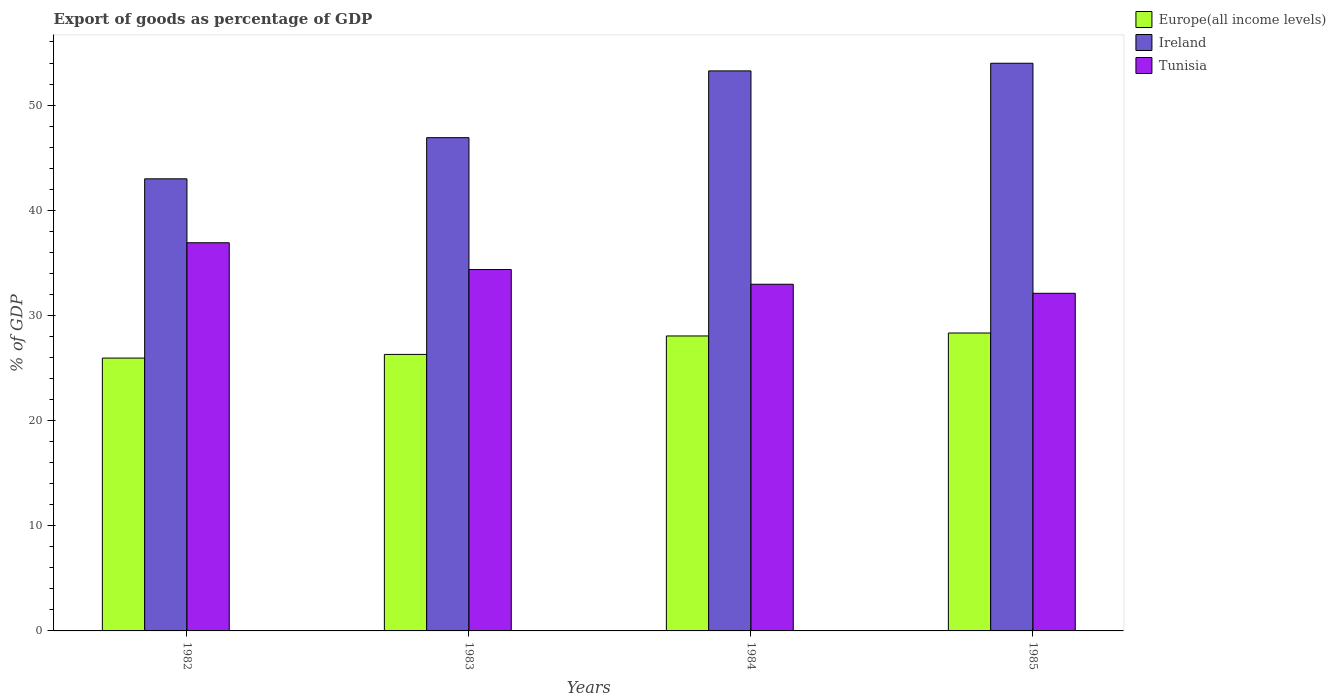How many groups of bars are there?
Provide a short and direct response. 4. Are the number of bars per tick equal to the number of legend labels?
Offer a terse response. Yes. Are the number of bars on each tick of the X-axis equal?
Provide a short and direct response. Yes. How many bars are there on the 2nd tick from the left?
Your answer should be compact. 3. What is the label of the 2nd group of bars from the left?
Offer a very short reply. 1983. What is the export of goods as percentage of GDP in Tunisia in 1983?
Your answer should be compact. 34.36. Across all years, what is the maximum export of goods as percentage of GDP in Europe(all income levels)?
Give a very brief answer. 28.33. Across all years, what is the minimum export of goods as percentage of GDP in Ireland?
Your answer should be compact. 42.99. In which year was the export of goods as percentage of GDP in Ireland maximum?
Give a very brief answer. 1985. In which year was the export of goods as percentage of GDP in Europe(all income levels) minimum?
Keep it short and to the point. 1982. What is the total export of goods as percentage of GDP in Europe(all income levels) in the graph?
Your answer should be compact. 108.61. What is the difference between the export of goods as percentage of GDP in Europe(all income levels) in 1983 and that in 1985?
Your answer should be very brief. -2.04. What is the difference between the export of goods as percentage of GDP in Europe(all income levels) in 1985 and the export of goods as percentage of GDP in Tunisia in 1984?
Offer a terse response. -4.64. What is the average export of goods as percentage of GDP in Tunisia per year?
Your answer should be very brief. 34.09. In the year 1985, what is the difference between the export of goods as percentage of GDP in Ireland and export of goods as percentage of GDP in Europe(all income levels)?
Give a very brief answer. 25.65. In how many years, is the export of goods as percentage of GDP in Europe(all income levels) greater than 44 %?
Provide a short and direct response. 0. What is the ratio of the export of goods as percentage of GDP in Tunisia in 1982 to that in 1983?
Offer a very short reply. 1.07. What is the difference between the highest and the second highest export of goods as percentage of GDP in Ireland?
Your answer should be very brief. 0.73. What is the difference between the highest and the lowest export of goods as percentage of GDP in Europe(all income levels)?
Provide a succinct answer. 2.38. What does the 3rd bar from the left in 1982 represents?
Provide a short and direct response. Tunisia. What does the 1st bar from the right in 1985 represents?
Give a very brief answer. Tunisia. How many bars are there?
Give a very brief answer. 12. Are all the bars in the graph horizontal?
Keep it short and to the point. No. How many years are there in the graph?
Provide a succinct answer. 4. What is the difference between two consecutive major ticks on the Y-axis?
Provide a succinct answer. 10. Does the graph contain any zero values?
Your response must be concise. No. Does the graph contain grids?
Make the answer very short. No. Where does the legend appear in the graph?
Your answer should be very brief. Top right. What is the title of the graph?
Provide a succinct answer. Export of goods as percentage of GDP. Does "Congo (Democratic)" appear as one of the legend labels in the graph?
Offer a very short reply. No. What is the label or title of the X-axis?
Make the answer very short. Years. What is the label or title of the Y-axis?
Offer a very short reply. % of GDP. What is the % of GDP in Europe(all income levels) in 1982?
Your response must be concise. 25.94. What is the % of GDP in Ireland in 1982?
Provide a short and direct response. 42.99. What is the % of GDP in Tunisia in 1982?
Your answer should be very brief. 36.91. What is the % of GDP in Europe(all income levels) in 1983?
Offer a very short reply. 26.29. What is the % of GDP in Ireland in 1983?
Your answer should be very brief. 46.9. What is the % of GDP of Tunisia in 1983?
Your answer should be very brief. 34.36. What is the % of GDP in Europe(all income levels) in 1984?
Give a very brief answer. 28.05. What is the % of GDP in Ireland in 1984?
Keep it short and to the point. 53.25. What is the % of GDP in Tunisia in 1984?
Give a very brief answer. 32.96. What is the % of GDP in Europe(all income levels) in 1985?
Make the answer very short. 28.33. What is the % of GDP in Ireland in 1985?
Your response must be concise. 53.98. What is the % of GDP of Tunisia in 1985?
Offer a very short reply. 32.1. Across all years, what is the maximum % of GDP of Europe(all income levels)?
Provide a succinct answer. 28.33. Across all years, what is the maximum % of GDP in Ireland?
Your response must be concise. 53.98. Across all years, what is the maximum % of GDP in Tunisia?
Make the answer very short. 36.91. Across all years, what is the minimum % of GDP in Europe(all income levels)?
Your answer should be compact. 25.94. Across all years, what is the minimum % of GDP in Ireland?
Ensure brevity in your answer.  42.99. Across all years, what is the minimum % of GDP in Tunisia?
Give a very brief answer. 32.1. What is the total % of GDP of Europe(all income levels) in the graph?
Ensure brevity in your answer.  108.61. What is the total % of GDP of Ireland in the graph?
Provide a succinct answer. 197.12. What is the total % of GDP in Tunisia in the graph?
Offer a very short reply. 136.34. What is the difference between the % of GDP of Europe(all income levels) in 1982 and that in 1983?
Keep it short and to the point. -0.35. What is the difference between the % of GDP of Ireland in 1982 and that in 1983?
Keep it short and to the point. -3.91. What is the difference between the % of GDP of Tunisia in 1982 and that in 1983?
Make the answer very short. 2.55. What is the difference between the % of GDP in Europe(all income levels) in 1982 and that in 1984?
Make the answer very short. -2.1. What is the difference between the % of GDP in Ireland in 1982 and that in 1984?
Offer a very short reply. -10.26. What is the difference between the % of GDP in Tunisia in 1982 and that in 1984?
Provide a short and direct response. 3.95. What is the difference between the % of GDP in Europe(all income levels) in 1982 and that in 1985?
Ensure brevity in your answer.  -2.38. What is the difference between the % of GDP of Ireland in 1982 and that in 1985?
Provide a short and direct response. -10.99. What is the difference between the % of GDP in Tunisia in 1982 and that in 1985?
Keep it short and to the point. 4.81. What is the difference between the % of GDP in Europe(all income levels) in 1983 and that in 1984?
Offer a terse response. -1.75. What is the difference between the % of GDP of Ireland in 1983 and that in 1984?
Your answer should be compact. -6.35. What is the difference between the % of GDP in Tunisia in 1983 and that in 1984?
Offer a terse response. 1.4. What is the difference between the % of GDP in Europe(all income levels) in 1983 and that in 1985?
Offer a very short reply. -2.04. What is the difference between the % of GDP in Ireland in 1983 and that in 1985?
Make the answer very short. -7.08. What is the difference between the % of GDP in Tunisia in 1983 and that in 1985?
Keep it short and to the point. 2.26. What is the difference between the % of GDP of Europe(all income levels) in 1984 and that in 1985?
Your answer should be very brief. -0.28. What is the difference between the % of GDP of Ireland in 1984 and that in 1985?
Offer a very short reply. -0.73. What is the difference between the % of GDP in Tunisia in 1984 and that in 1985?
Provide a short and direct response. 0.86. What is the difference between the % of GDP in Europe(all income levels) in 1982 and the % of GDP in Ireland in 1983?
Offer a terse response. -20.96. What is the difference between the % of GDP of Europe(all income levels) in 1982 and the % of GDP of Tunisia in 1983?
Ensure brevity in your answer.  -8.42. What is the difference between the % of GDP of Ireland in 1982 and the % of GDP of Tunisia in 1983?
Offer a terse response. 8.62. What is the difference between the % of GDP of Europe(all income levels) in 1982 and the % of GDP of Ireland in 1984?
Your answer should be compact. -27.31. What is the difference between the % of GDP of Europe(all income levels) in 1982 and the % of GDP of Tunisia in 1984?
Your response must be concise. -7.02. What is the difference between the % of GDP of Ireland in 1982 and the % of GDP of Tunisia in 1984?
Ensure brevity in your answer.  10.03. What is the difference between the % of GDP of Europe(all income levels) in 1982 and the % of GDP of Ireland in 1985?
Keep it short and to the point. -28.03. What is the difference between the % of GDP of Europe(all income levels) in 1982 and the % of GDP of Tunisia in 1985?
Your answer should be very brief. -6.16. What is the difference between the % of GDP in Ireland in 1982 and the % of GDP in Tunisia in 1985?
Keep it short and to the point. 10.89. What is the difference between the % of GDP in Europe(all income levels) in 1983 and the % of GDP in Ireland in 1984?
Your answer should be very brief. -26.96. What is the difference between the % of GDP of Europe(all income levels) in 1983 and the % of GDP of Tunisia in 1984?
Your answer should be compact. -6.67. What is the difference between the % of GDP of Ireland in 1983 and the % of GDP of Tunisia in 1984?
Your answer should be compact. 13.94. What is the difference between the % of GDP in Europe(all income levels) in 1983 and the % of GDP in Ireland in 1985?
Your response must be concise. -27.69. What is the difference between the % of GDP of Europe(all income levels) in 1983 and the % of GDP of Tunisia in 1985?
Keep it short and to the point. -5.81. What is the difference between the % of GDP in Ireland in 1983 and the % of GDP in Tunisia in 1985?
Offer a terse response. 14.8. What is the difference between the % of GDP of Europe(all income levels) in 1984 and the % of GDP of Ireland in 1985?
Offer a very short reply. -25.93. What is the difference between the % of GDP in Europe(all income levels) in 1984 and the % of GDP in Tunisia in 1985?
Your answer should be very brief. -4.06. What is the difference between the % of GDP of Ireland in 1984 and the % of GDP of Tunisia in 1985?
Your answer should be very brief. 21.15. What is the average % of GDP of Europe(all income levels) per year?
Your answer should be very brief. 27.15. What is the average % of GDP of Ireland per year?
Make the answer very short. 49.28. What is the average % of GDP of Tunisia per year?
Provide a succinct answer. 34.09. In the year 1982, what is the difference between the % of GDP in Europe(all income levels) and % of GDP in Ireland?
Provide a succinct answer. -17.04. In the year 1982, what is the difference between the % of GDP in Europe(all income levels) and % of GDP in Tunisia?
Offer a very short reply. -10.97. In the year 1982, what is the difference between the % of GDP of Ireland and % of GDP of Tunisia?
Ensure brevity in your answer.  6.08. In the year 1983, what is the difference between the % of GDP in Europe(all income levels) and % of GDP in Ireland?
Your response must be concise. -20.61. In the year 1983, what is the difference between the % of GDP in Europe(all income levels) and % of GDP in Tunisia?
Ensure brevity in your answer.  -8.07. In the year 1983, what is the difference between the % of GDP of Ireland and % of GDP of Tunisia?
Offer a very short reply. 12.54. In the year 1984, what is the difference between the % of GDP in Europe(all income levels) and % of GDP in Ireland?
Offer a very short reply. -25.2. In the year 1984, what is the difference between the % of GDP in Europe(all income levels) and % of GDP in Tunisia?
Provide a short and direct response. -4.92. In the year 1984, what is the difference between the % of GDP in Ireland and % of GDP in Tunisia?
Keep it short and to the point. 20.29. In the year 1985, what is the difference between the % of GDP in Europe(all income levels) and % of GDP in Ireland?
Ensure brevity in your answer.  -25.65. In the year 1985, what is the difference between the % of GDP in Europe(all income levels) and % of GDP in Tunisia?
Offer a very short reply. -3.78. In the year 1985, what is the difference between the % of GDP of Ireland and % of GDP of Tunisia?
Ensure brevity in your answer.  21.87. What is the ratio of the % of GDP of Europe(all income levels) in 1982 to that in 1983?
Provide a short and direct response. 0.99. What is the ratio of the % of GDP in Ireland in 1982 to that in 1983?
Offer a very short reply. 0.92. What is the ratio of the % of GDP of Tunisia in 1982 to that in 1983?
Keep it short and to the point. 1.07. What is the ratio of the % of GDP in Europe(all income levels) in 1982 to that in 1984?
Provide a short and direct response. 0.93. What is the ratio of the % of GDP of Ireland in 1982 to that in 1984?
Offer a very short reply. 0.81. What is the ratio of the % of GDP in Tunisia in 1982 to that in 1984?
Keep it short and to the point. 1.12. What is the ratio of the % of GDP of Europe(all income levels) in 1982 to that in 1985?
Give a very brief answer. 0.92. What is the ratio of the % of GDP in Ireland in 1982 to that in 1985?
Your answer should be compact. 0.8. What is the ratio of the % of GDP in Tunisia in 1982 to that in 1985?
Provide a succinct answer. 1.15. What is the ratio of the % of GDP of Europe(all income levels) in 1983 to that in 1984?
Give a very brief answer. 0.94. What is the ratio of the % of GDP in Ireland in 1983 to that in 1984?
Your answer should be very brief. 0.88. What is the ratio of the % of GDP in Tunisia in 1983 to that in 1984?
Provide a succinct answer. 1.04. What is the ratio of the % of GDP in Europe(all income levels) in 1983 to that in 1985?
Your answer should be compact. 0.93. What is the ratio of the % of GDP of Ireland in 1983 to that in 1985?
Offer a terse response. 0.87. What is the ratio of the % of GDP of Tunisia in 1983 to that in 1985?
Provide a short and direct response. 1.07. What is the ratio of the % of GDP in Ireland in 1984 to that in 1985?
Give a very brief answer. 0.99. What is the ratio of the % of GDP of Tunisia in 1984 to that in 1985?
Your answer should be very brief. 1.03. What is the difference between the highest and the second highest % of GDP in Europe(all income levels)?
Your response must be concise. 0.28. What is the difference between the highest and the second highest % of GDP of Ireland?
Your answer should be compact. 0.73. What is the difference between the highest and the second highest % of GDP in Tunisia?
Give a very brief answer. 2.55. What is the difference between the highest and the lowest % of GDP of Europe(all income levels)?
Give a very brief answer. 2.38. What is the difference between the highest and the lowest % of GDP in Ireland?
Provide a short and direct response. 10.99. What is the difference between the highest and the lowest % of GDP of Tunisia?
Offer a terse response. 4.81. 